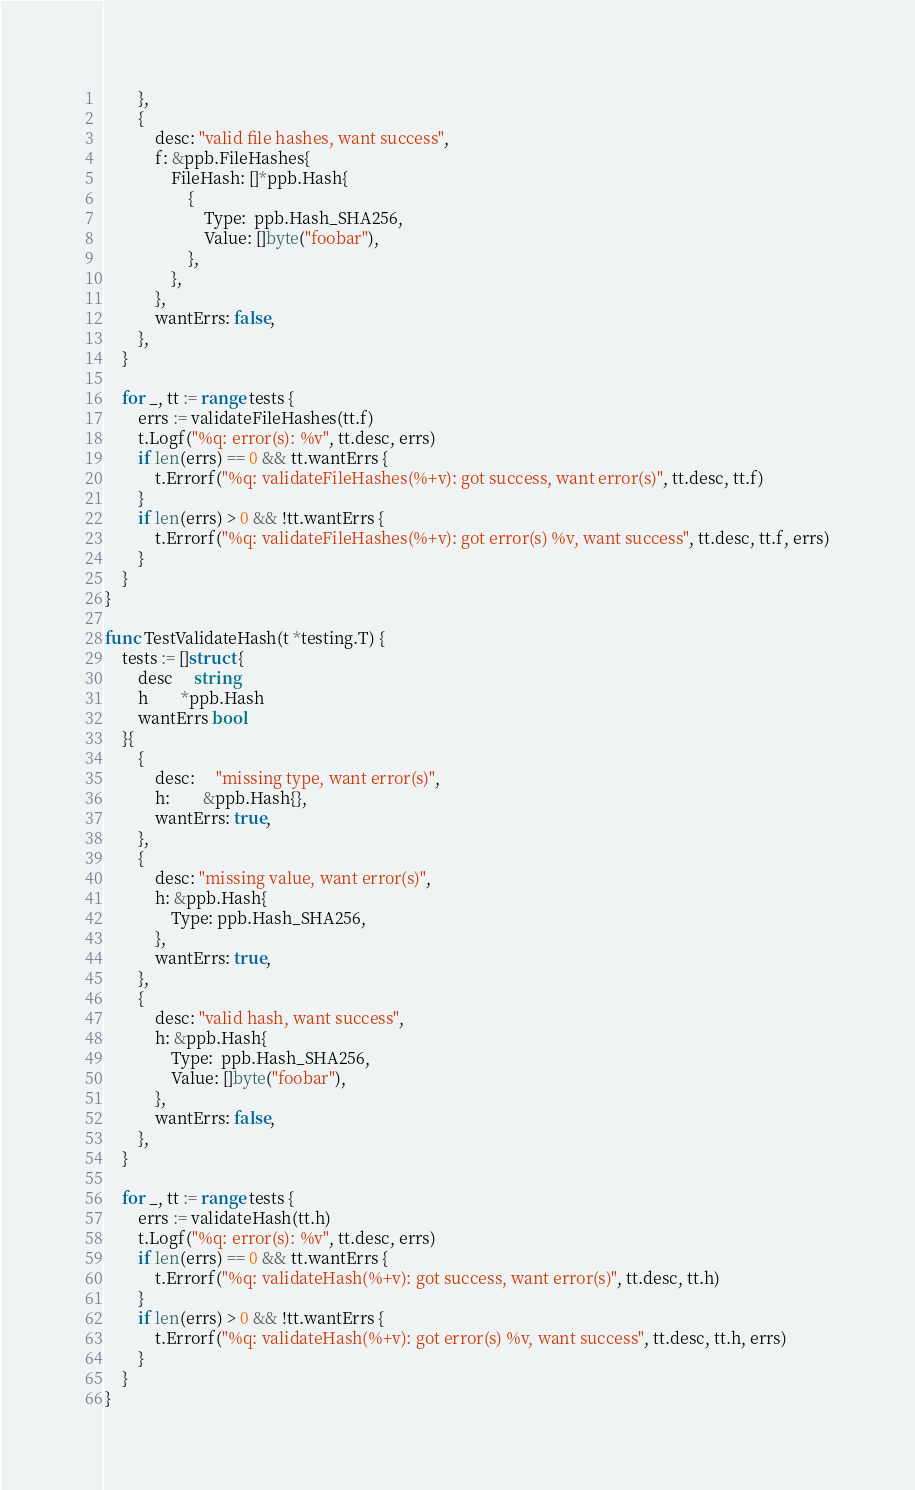<code> <loc_0><loc_0><loc_500><loc_500><_Go_>		},
		{
			desc: "valid file hashes, want success",
			f: &ppb.FileHashes{
				FileHash: []*ppb.Hash{
					{
						Type:  ppb.Hash_SHA256,
						Value: []byte("foobar"),
					},
				},
			},
			wantErrs: false,
		},
	}

	for _, tt := range tests {
		errs := validateFileHashes(tt.f)
		t.Logf("%q: error(s): %v", tt.desc, errs)
		if len(errs) == 0 && tt.wantErrs {
			t.Errorf("%q: validateFileHashes(%+v): got success, want error(s)", tt.desc, tt.f)
		}
		if len(errs) > 0 && !tt.wantErrs {
			t.Errorf("%q: validateFileHashes(%+v): got error(s) %v, want success", tt.desc, tt.f, errs)
		}
	}
}

func TestValidateHash(t *testing.T) {
	tests := []struct {
		desc     string
		h        *ppb.Hash
		wantErrs bool
	}{
		{
			desc:     "missing type, want error(s)",
			h:        &ppb.Hash{},
			wantErrs: true,
		},
		{
			desc: "missing value, want error(s)",
			h: &ppb.Hash{
				Type: ppb.Hash_SHA256,
			},
			wantErrs: true,
		},
		{
			desc: "valid hash, want success",
			h: &ppb.Hash{
				Type:  ppb.Hash_SHA256,
				Value: []byte("foobar"),
			},
			wantErrs: false,
		},
	}

	for _, tt := range tests {
		errs := validateHash(tt.h)
		t.Logf("%q: error(s): %v", tt.desc, errs)
		if len(errs) == 0 && tt.wantErrs {
			t.Errorf("%q: validateHash(%+v): got success, want error(s)", tt.desc, tt.h)
		}
		if len(errs) > 0 && !tt.wantErrs {
			t.Errorf("%q: validateHash(%+v): got error(s) %v, want success", tt.desc, tt.h, errs)
		}
	}
}
</code> 